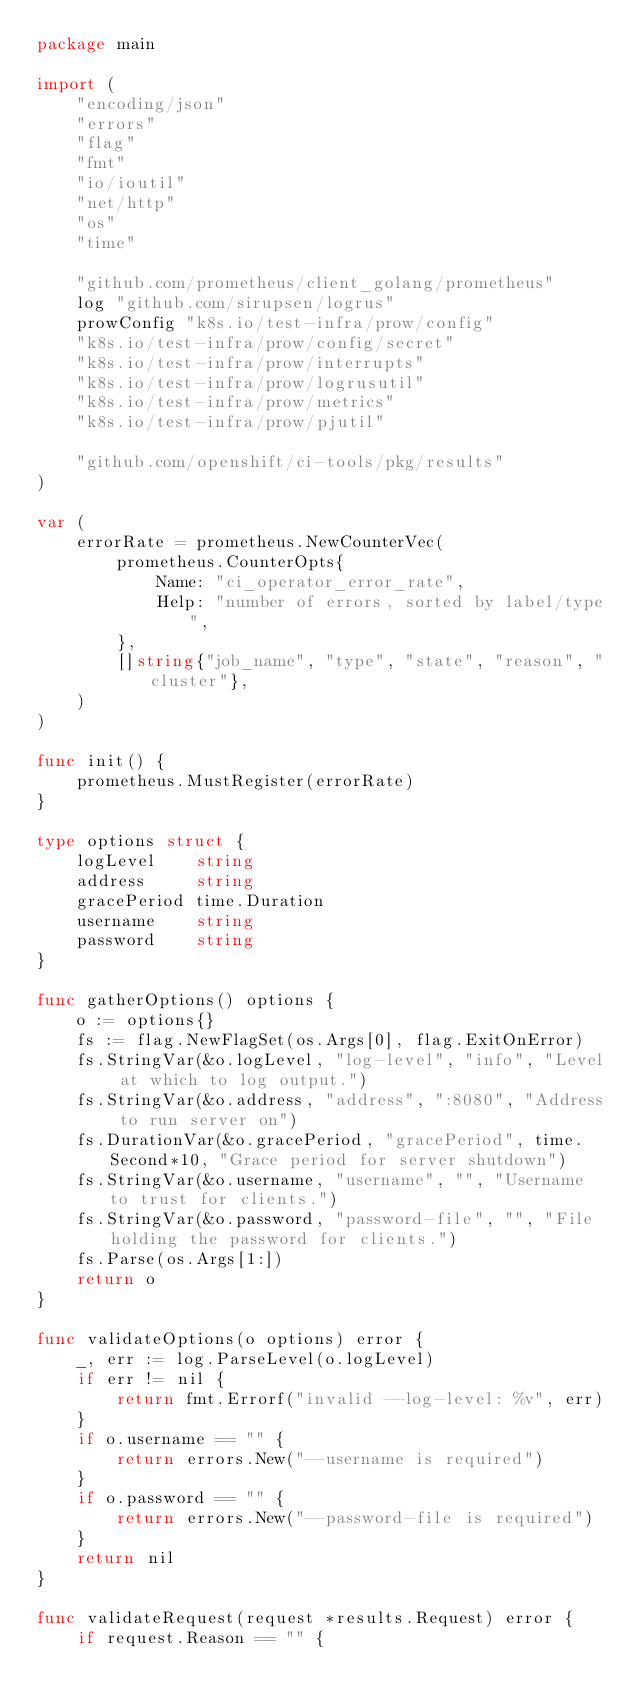<code> <loc_0><loc_0><loc_500><loc_500><_Go_>package main

import (
	"encoding/json"
	"errors"
	"flag"
	"fmt"
	"io/ioutil"
	"net/http"
	"os"
	"time"

	"github.com/prometheus/client_golang/prometheus"
	log "github.com/sirupsen/logrus"
	prowConfig "k8s.io/test-infra/prow/config"
	"k8s.io/test-infra/prow/config/secret"
	"k8s.io/test-infra/prow/interrupts"
	"k8s.io/test-infra/prow/logrusutil"
	"k8s.io/test-infra/prow/metrics"
	"k8s.io/test-infra/prow/pjutil"

	"github.com/openshift/ci-tools/pkg/results"
)

var (
	errorRate = prometheus.NewCounterVec(
		prometheus.CounterOpts{
			Name: "ci_operator_error_rate",
			Help: "number of errors, sorted by label/type",
		},
		[]string{"job_name", "type", "state", "reason", "cluster"},
	)
)

func init() {
	prometheus.MustRegister(errorRate)
}

type options struct {
	logLevel    string
	address     string
	gracePeriod time.Duration
	username    string
	password    string
}

func gatherOptions() options {
	o := options{}
	fs := flag.NewFlagSet(os.Args[0], flag.ExitOnError)
	fs.StringVar(&o.logLevel, "log-level", "info", "Level at which to log output.")
	fs.StringVar(&o.address, "address", ":8080", "Address to run server on")
	fs.DurationVar(&o.gracePeriod, "gracePeriod", time.Second*10, "Grace period for server shutdown")
	fs.StringVar(&o.username, "username", "", "Username to trust for clients.")
	fs.StringVar(&o.password, "password-file", "", "File holding the password for clients.")
	fs.Parse(os.Args[1:])
	return o
}

func validateOptions(o options) error {
	_, err := log.ParseLevel(o.logLevel)
	if err != nil {
		return fmt.Errorf("invalid --log-level: %v", err)
	}
	if o.username == "" {
		return errors.New("--username is required")
	}
	if o.password == "" {
		return errors.New("--password-file is required")
	}
	return nil
}

func validateRequest(request *results.Request) error {
	if request.Reason == "" {</code> 